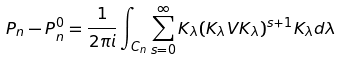Convert formula to latex. <formula><loc_0><loc_0><loc_500><loc_500>P _ { n } - P _ { n } ^ { 0 } = \frac { 1 } { 2 \pi i } \int _ { C _ { n } } \sum _ { s = 0 } ^ { \infty } K _ { \lambda } ( K _ { \lambda } V K _ { \lambda } ) ^ { s + 1 } K _ { \lambda } d \lambda</formula> 